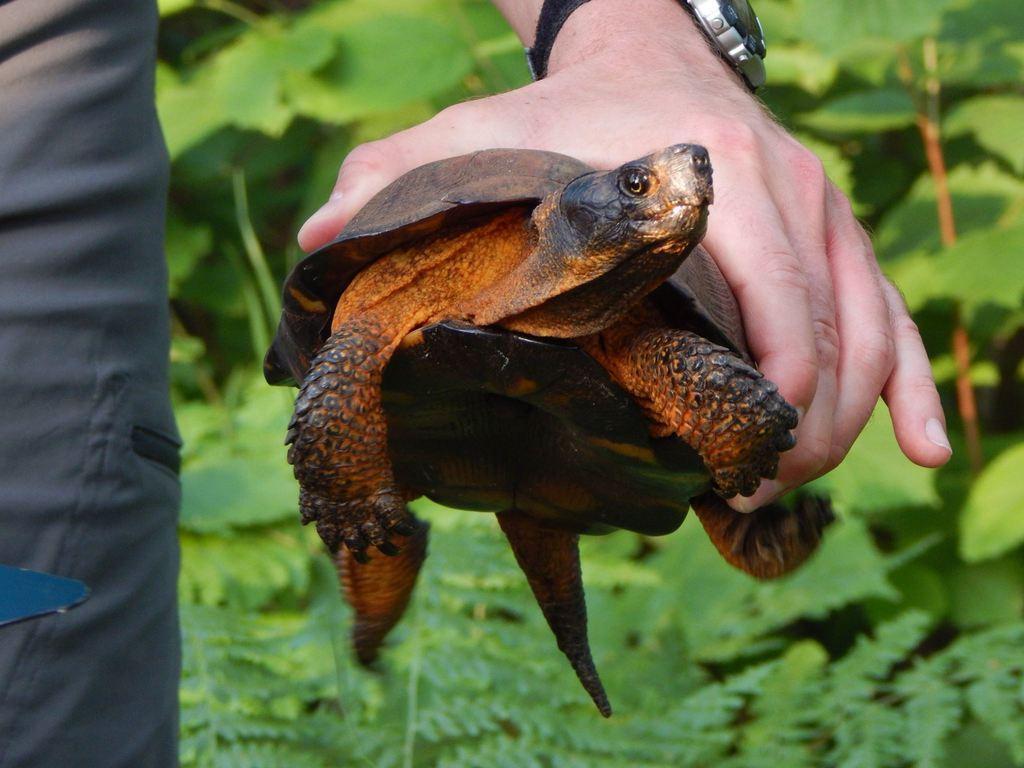Describe this image in one or two sentences. In this image there is a hand of a person holding a tortoise. There is a watch to the wrist. To the left there is a leg of a person. In the background there are plants. 